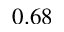<formula> <loc_0><loc_0><loc_500><loc_500>0 . 6 8</formula> 